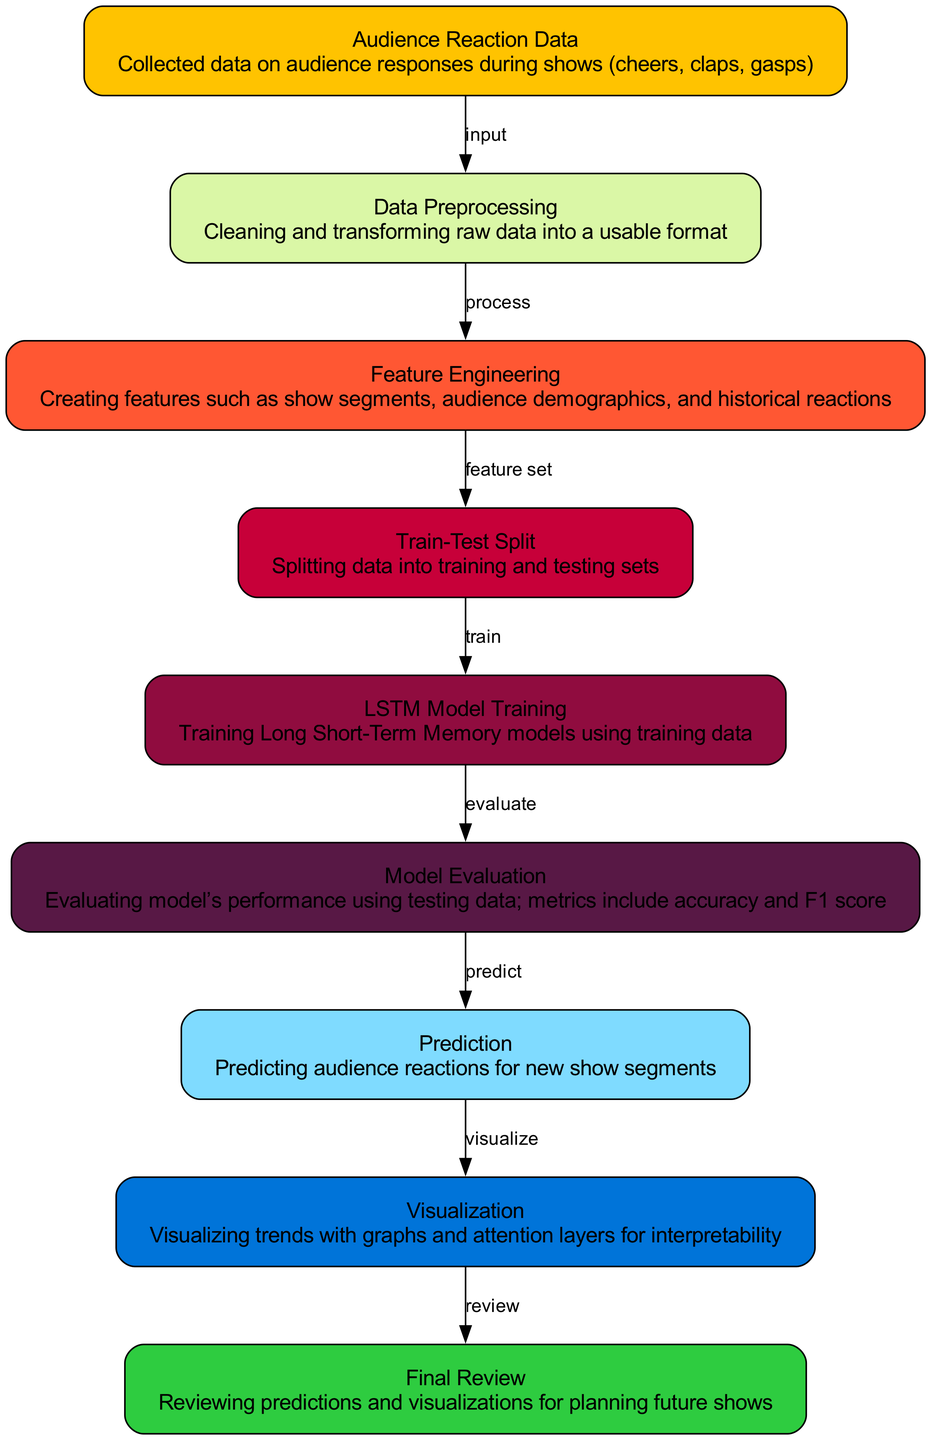What is the first node in the diagram? The first node in the diagram is identified as "Audience Reaction Data," which is indicated by its position and label.
Answer: Audience Reaction Data How many edges are in the diagram? By counting the connections (arrows) between nodes, there are a total of eight edges present in the diagram.
Answer: Eight Which node processes the audience reaction data? The node that processes the audience reaction data is "Data Preprocessing," as it follows directly from the first node indicating that it receives input from it.
Answer: Data Preprocessing What is the last step in the process? The last step in the process is represented by the "Final Review," which follows from the final prediction visualization step, indicating the conclusion of the flow.
Answer: Final Review What relationship exists between "Model Evaluation" and "Prediction"? The relationship is that "Model Evaluation" leads to "Prediction," indicating that after evaluating the model's performance, predictions on audience reactions are made next.
Answer: Predict What does the "Visualization" node depict? The "Visualization" node depicts the trends of audience reactions as graphs and attention layers to enhance interpretability, showing a focus on representing the prediction results.
Answer: Trends with graphs and attention layers Which node follows "Train-Test Split"? The node that follows "Train-Test Split" is "LSTM Model Training," which directly receives the training data after the split is done.
Answer: LSTM Model Training What type of model is being trained in this diagram? The type of model being trained in this diagram is an LSTM (Long Short-Term Memory) model, as indicated by the specific node dedicated to this process in the diagram.
Answer: LSTM Model What is the purpose of "Feature Engineering"? The purpose of "Feature Engineering" is to create relevant features such as show segments, audience demographics, and historical reactions that are necessary for model training.
Answer: Creating relevant features 